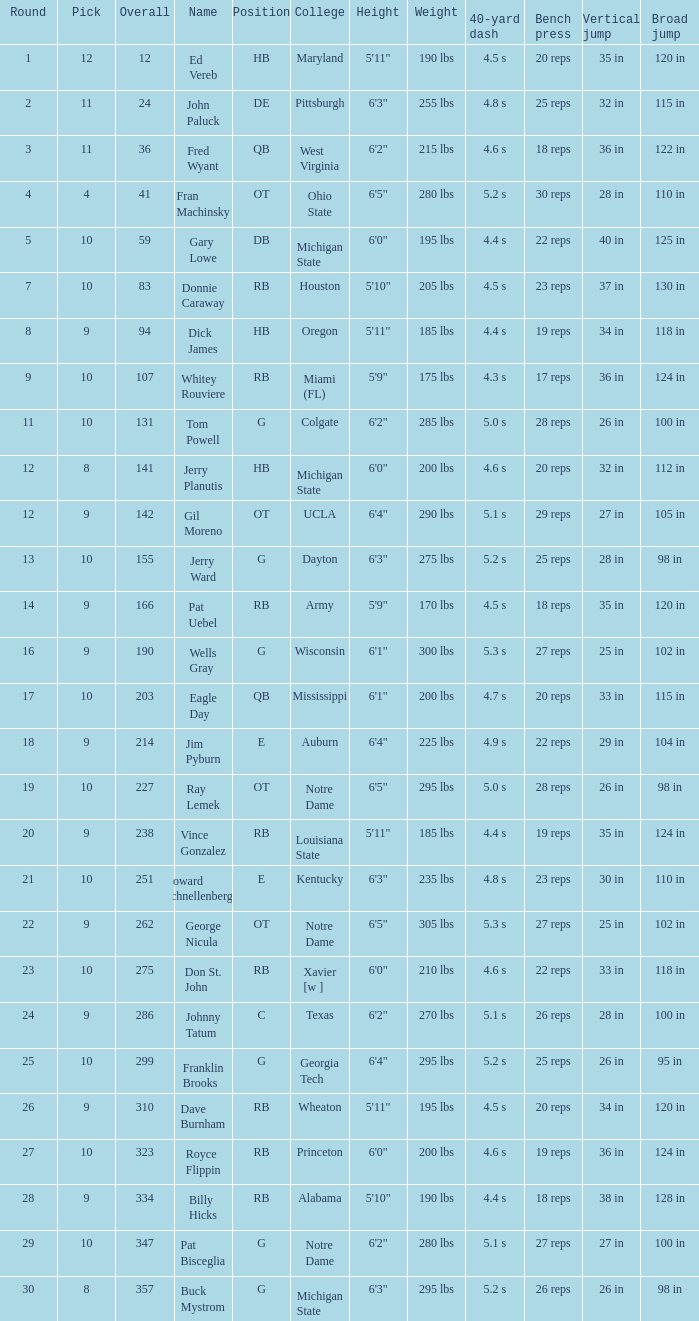What is the highest overall pick number for george nicula who had a pick smaller than 9? None. 